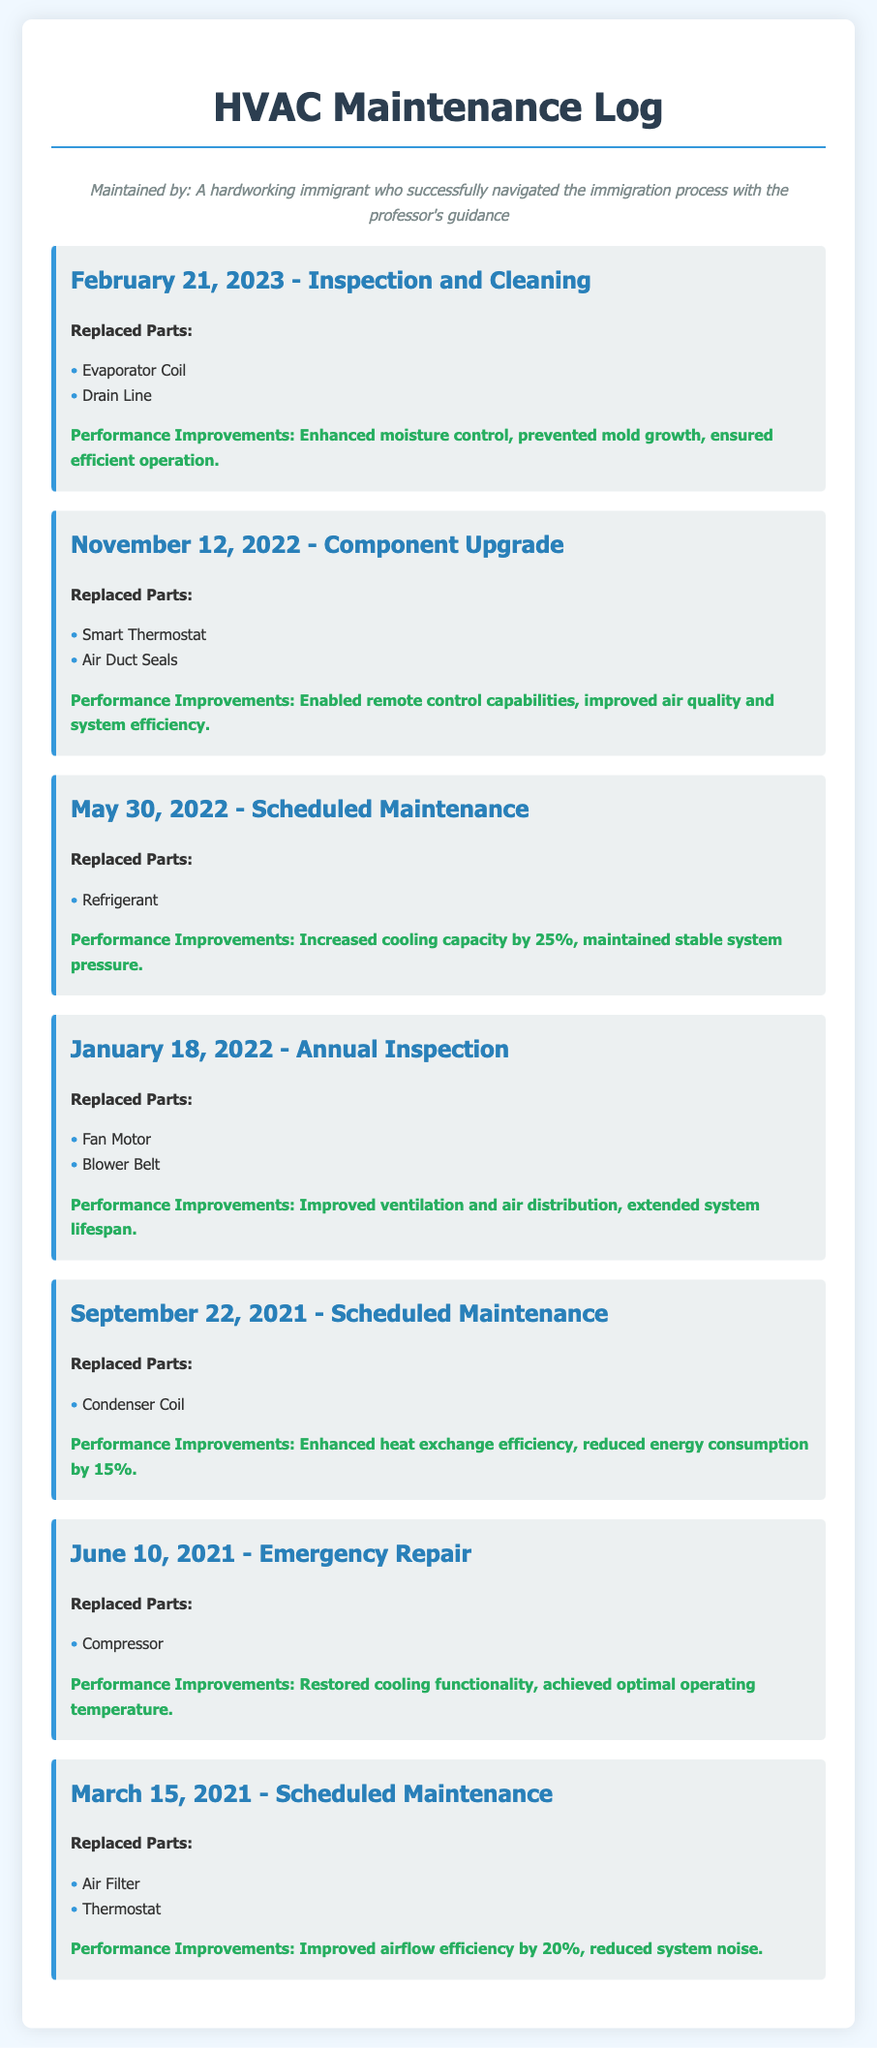What date was the last maintenance log entry? The last maintenance log entry date is the most recent date listed in the document, which is February 21, 2023.
Answer: February 21, 2023 How many parts were replaced during the November 12, 2022 entry? The number of parts replaced in the November 12, 2022 entry can be found in the corresponding section, which lists two replaced parts.
Answer: 2 What performance improvement was noted for the May 30, 2022 maintenance? The performance improvement for the May 30, 2022 maintenance can be found in the performance section, which states "Increased cooling capacity by 25%."
Answer: Increased cooling capacity by 25% Which part was replaced during the emergency repair on June 10, 2021? The specific part replaced during the emergency repair on June 10, 2021 is listed under the replaced parts section, which shows "Compressor."
Answer: Compressor What is the stated performance improvement for the September 22, 2021 maintenance? The performance improvement for the September 22, 2021 maintenance is directly mentioned in the document, stating "Enhanced heat exchange efficiency, reduced energy consumption by 15%."
Answer: Reduced energy consumption by 15% What type of maintenance was performed on March 15, 2021? The type of maintenance performed on March 15, 2021 can be identified in the corresponding log entry, which is labeled as Scheduled Maintenance.
Answer: Scheduled Maintenance How many parts were replaced during the annual inspection on January 18, 2022? This can be determined by reviewing the list of replaced parts for the annual inspection on January 18, 2022, which mentions two parts were replaced.
Answer: 2 